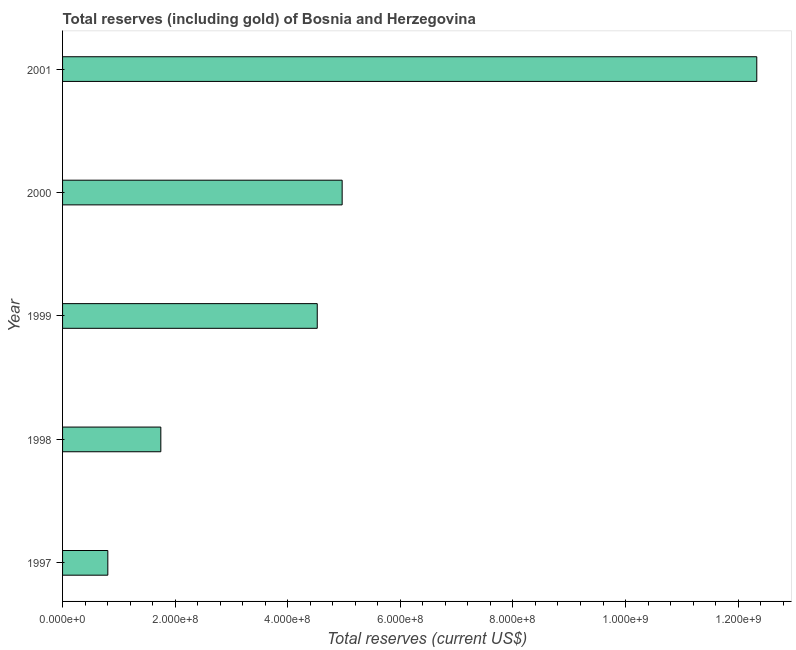Does the graph contain any zero values?
Keep it short and to the point. No. What is the title of the graph?
Offer a very short reply. Total reserves (including gold) of Bosnia and Herzegovina. What is the label or title of the X-axis?
Make the answer very short. Total reserves (current US$). What is the label or title of the Y-axis?
Give a very brief answer. Year. What is the total reserves (including gold) in 1997?
Provide a succinct answer. 8.04e+07. Across all years, what is the maximum total reserves (including gold)?
Provide a short and direct response. 1.23e+09. Across all years, what is the minimum total reserves (including gold)?
Your answer should be very brief. 8.04e+07. In which year was the total reserves (including gold) maximum?
Offer a very short reply. 2001. What is the sum of the total reserves (including gold)?
Your response must be concise. 2.44e+09. What is the difference between the total reserves (including gold) in 1999 and 2001?
Your response must be concise. -7.81e+08. What is the average total reserves (including gold) per year?
Your response must be concise. 4.87e+08. What is the median total reserves (including gold)?
Offer a terse response. 4.52e+08. What is the ratio of the total reserves (including gold) in 2000 to that in 2001?
Give a very brief answer. 0.4. Is the total reserves (including gold) in 1998 less than that in 2000?
Provide a succinct answer. Yes. What is the difference between the highest and the second highest total reserves (including gold)?
Your response must be concise. 7.37e+08. Is the sum of the total reserves (including gold) in 1998 and 1999 greater than the maximum total reserves (including gold) across all years?
Your response must be concise. No. What is the difference between the highest and the lowest total reserves (including gold)?
Your answer should be compact. 1.15e+09. How many bars are there?
Provide a short and direct response. 5. How many years are there in the graph?
Your response must be concise. 5. What is the Total reserves (current US$) in 1997?
Your answer should be very brief. 8.04e+07. What is the Total reserves (current US$) of 1998?
Provide a succinct answer. 1.75e+08. What is the Total reserves (current US$) of 1999?
Ensure brevity in your answer.  4.52e+08. What is the Total reserves (current US$) of 2000?
Offer a very short reply. 4.97e+08. What is the Total reserves (current US$) of 2001?
Your response must be concise. 1.23e+09. What is the difference between the Total reserves (current US$) in 1997 and 1998?
Provide a succinct answer. -9.41e+07. What is the difference between the Total reserves (current US$) in 1997 and 1999?
Make the answer very short. -3.72e+08. What is the difference between the Total reserves (current US$) in 1997 and 2000?
Your answer should be compact. -4.16e+08. What is the difference between the Total reserves (current US$) in 1997 and 2001?
Give a very brief answer. -1.15e+09. What is the difference between the Total reserves (current US$) in 1998 and 1999?
Offer a terse response. -2.78e+08. What is the difference between the Total reserves (current US$) in 1998 and 2000?
Give a very brief answer. -3.22e+08. What is the difference between the Total reserves (current US$) in 1998 and 2001?
Your answer should be compact. -1.06e+09. What is the difference between the Total reserves (current US$) in 1999 and 2000?
Ensure brevity in your answer.  -4.42e+07. What is the difference between the Total reserves (current US$) in 1999 and 2001?
Provide a short and direct response. -7.81e+08. What is the difference between the Total reserves (current US$) in 2000 and 2001?
Your response must be concise. -7.37e+08. What is the ratio of the Total reserves (current US$) in 1997 to that in 1998?
Provide a succinct answer. 0.46. What is the ratio of the Total reserves (current US$) in 1997 to that in 1999?
Your response must be concise. 0.18. What is the ratio of the Total reserves (current US$) in 1997 to that in 2000?
Provide a succinct answer. 0.16. What is the ratio of the Total reserves (current US$) in 1997 to that in 2001?
Provide a short and direct response. 0.07. What is the ratio of the Total reserves (current US$) in 1998 to that in 1999?
Give a very brief answer. 0.39. What is the ratio of the Total reserves (current US$) in 1998 to that in 2000?
Your answer should be very brief. 0.35. What is the ratio of the Total reserves (current US$) in 1998 to that in 2001?
Give a very brief answer. 0.14. What is the ratio of the Total reserves (current US$) in 1999 to that in 2000?
Make the answer very short. 0.91. What is the ratio of the Total reserves (current US$) in 1999 to that in 2001?
Provide a succinct answer. 0.37. What is the ratio of the Total reserves (current US$) in 2000 to that in 2001?
Offer a very short reply. 0.4. 